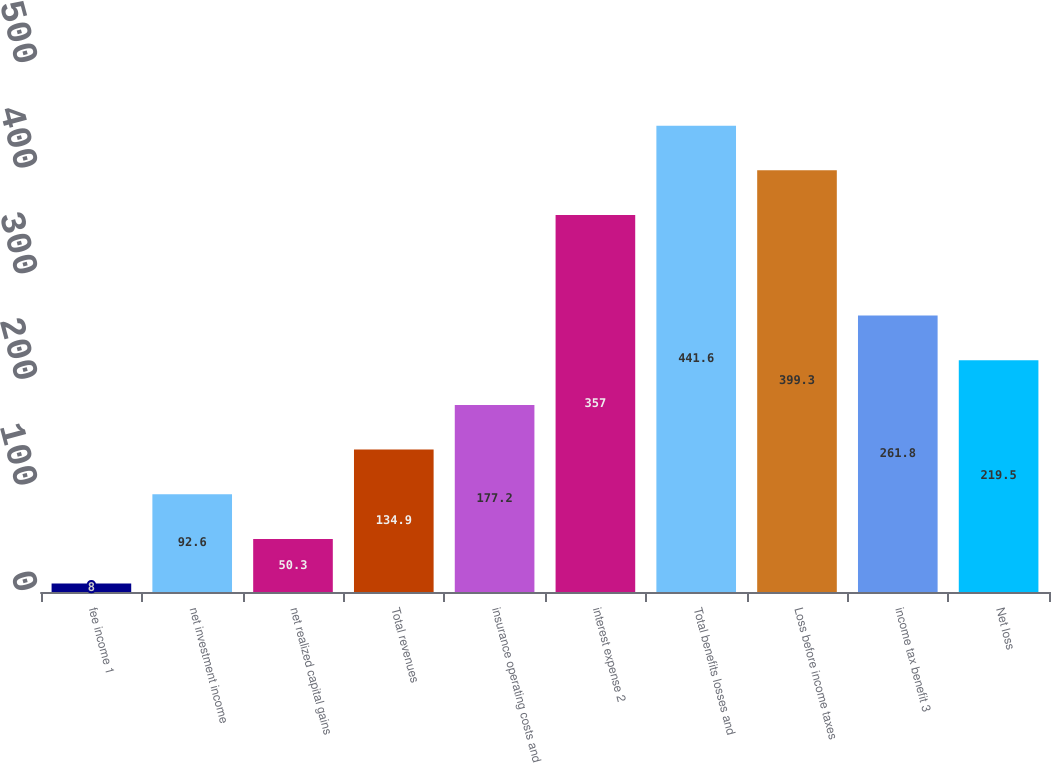Convert chart to OTSL. <chart><loc_0><loc_0><loc_500><loc_500><bar_chart><fcel>fee income 1<fcel>net investment income<fcel>net realized capital gains<fcel>Total revenues<fcel>insurance operating costs and<fcel>interest expense 2<fcel>Total benefits losses and<fcel>Loss before income taxes<fcel>income tax benefit 3<fcel>Net loss<nl><fcel>8<fcel>92.6<fcel>50.3<fcel>134.9<fcel>177.2<fcel>357<fcel>441.6<fcel>399.3<fcel>261.8<fcel>219.5<nl></chart> 